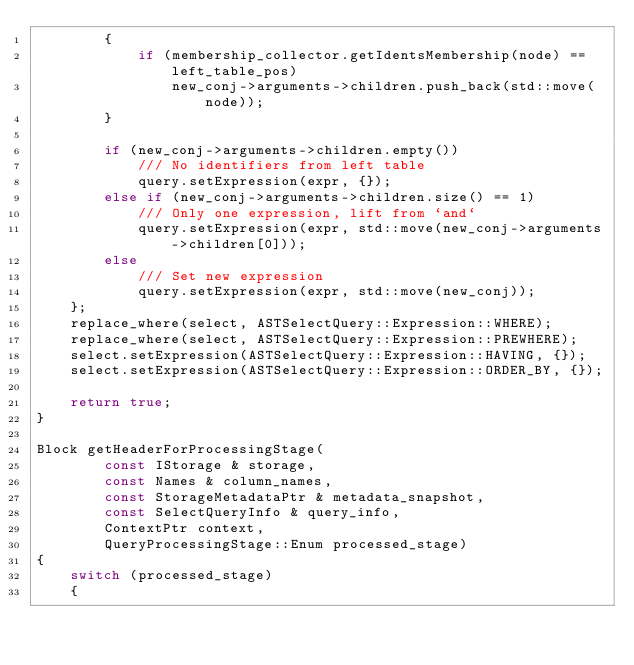Convert code to text. <code><loc_0><loc_0><loc_500><loc_500><_C++_>        {
            if (membership_collector.getIdentsMembership(node) == left_table_pos)
                new_conj->arguments->children.push_back(std::move(node));
        }

        if (new_conj->arguments->children.empty())
            /// No identifiers from left table
            query.setExpression(expr, {});
        else if (new_conj->arguments->children.size() == 1)
            /// Only one expression, lift from `and`
            query.setExpression(expr, std::move(new_conj->arguments->children[0]));
        else
            /// Set new expression
            query.setExpression(expr, std::move(new_conj));
    };
    replace_where(select, ASTSelectQuery::Expression::WHERE);
    replace_where(select, ASTSelectQuery::Expression::PREWHERE);
    select.setExpression(ASTSelectQuery::Expression::HAVING, {});
    select.setExpression(ASTSelectQuery::Expression::ORDER_BY, {});

    return true;
}

Block getHeaderForProcessingStage(
        const IStorage & storage,
        const Names & column_names,
        const StorageMetadataPtr & metadata_snapshot,
        const SelectQueryInfo & query_info,
        ContextPtr context,
        QueryProcessingStage::Enum processed_stage)
{
    switch (processed_stage)
    {</code> 